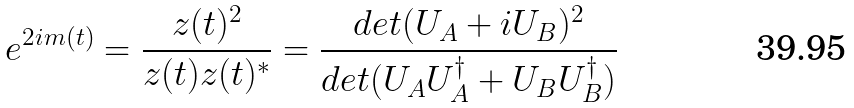<formula> <loc_0><loc_0><loc_500><loc_500>e ^ { 2 i m ( t ) } = \frac { z ( t ) ^ { 2 } } { z ( t ) z ( t ) ^ { * } } = \frac { d e t ( U _ { A } + i U _ { B } ) ^ { 2 } } { d e t ( U _ { A } U _ { A } ^ { \dag } + U _ { B } U _ { B } ^ { \dag } ) }</formula> 